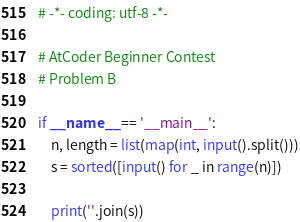<code> <loc_0><loc_0><loc_500><loc_500><_Python_># -*- coding: utf-8 -*-

# AtCoder Beginner Contest
# Problem B

if __name__ == '__main__':
    n, length = list(map(int, input().split()))
    s = sorted([input() for _ in range(n)])

    print(''.join(s))
</code> 